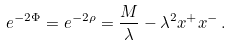<formula> <loc_0><loc_0><loc_500><loc_500>e ^ { - 2 \Phi } = e ^ { - 2 \rho } = { \frac { M } { \lambda } } - \lambda ^ { 2 } x ^ { + } x ^ { - } \, .</formula> 